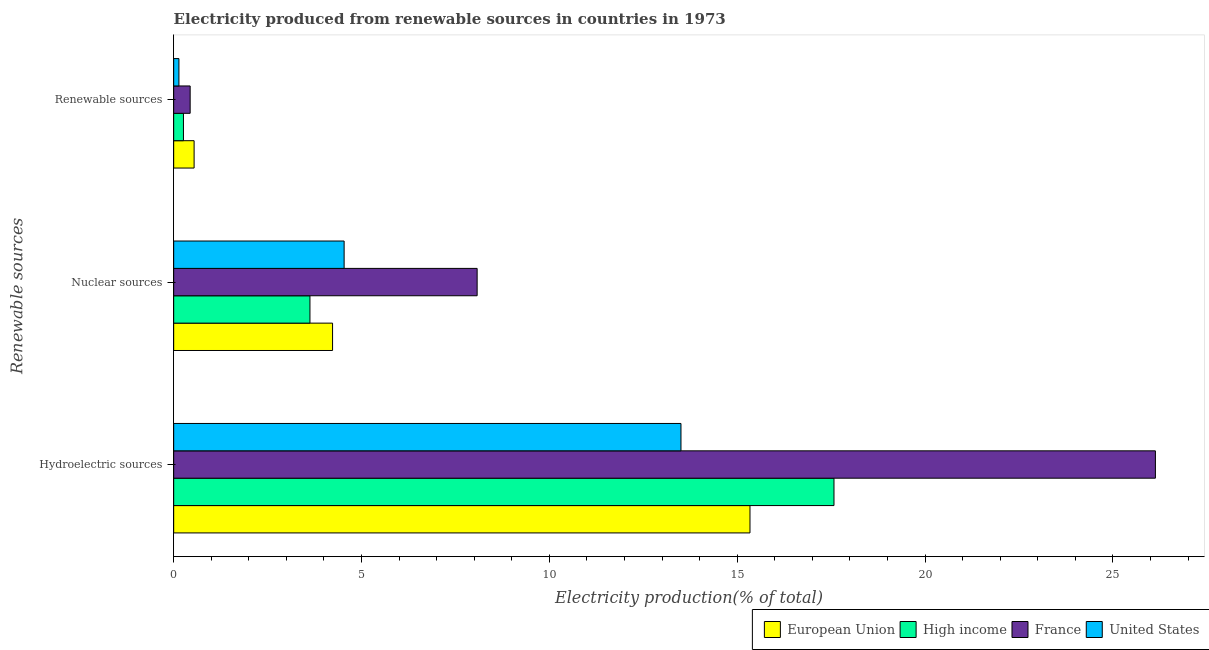How many groups of bars are there?
Your response must be concise. 3. Are the number of bars on each tick of the Y-axis equal?
Your answer should be very brief. Yes. How many bars are there on the 1st tick from the top?
Provide a short and direct response. 4. How many bars are there on the 2nd tick from the bottom?
Keep it short and to the point. 4. What is the label of the 1st group of bars from the top?
Provide a succinct answer. Renewable sources. What is the percentage of electricity produced by hydroelectric sources in United States?
Keep it short and to the point. 13.5. Across all countries, what is the maximum percentage of electricity produced by hydroelectric sources?
Make the answer very short. 26.13. Across all countries, what is the minimum percentage of electricity produced by hydroelectric sources?
Offer a terse response. 13.5. In which country was the percentage of electricity produced by nuclear sources minimum?
Provide a short and direct response. High income. What is the total percentage of electricity produced by renewable sources in the graph?
Provide a succinct answer. 1.38. What is the difference between the percentage of electricity produced by hydroelectric sources in France and that in European Union?
Provide a short and direct response. 10.79. What is the difference between the percentage of electricity produced by renewable sources in France and the percentage of electricity produced by hydroelectric sources in High income?
Make the answer very short. -17.14. What is the average percentage of electricity produced by nuclear sources per country?
Your answer should be very brief. 5.12. What is the difference between the percentage of electricity produced by nuclear sources and percentage of electricity produced by renewable sources in France?
Offer a terse response. 7.64. What is the ratio of the percentage of electricity produced by nuclear sources in France to that in United States?
Your response must be concise. 1.78. Is the difference between the percentage of electricity produced by hydroelectric sources in France and High income greater than the difference between the percentage of electricity produced by renewable sources in France and High income?
Offer a very short reply. Yes. What is the difference between the highest and the second highest percentage of electricity produced by hydroelectric sources?
Give a very brief answer. 8.55. What is the difference between the highest and the lowest percentage of electricity produced by hydroelectric sources?
Give a very brief answer. 12.63. What does the 3rd bar from the top in Hydroelectric sources represents?
Provide a short and direct response. High income. What does the 4th bar from the bottom in Nuclear sources represents?
Provide a short and direct response. United States. Is it the case that in every country, the sum of the percentage of electricity produced by hydroelectric sources and percentage of electricity produced by nuclear sources is greater than the percentage of electricity produced by renewable sources?
Ensure brevity in your answer.  Yes. How many bars are there?
Make the answer very short. 12. How many countries are there in the graph?
Ensure brevity in your answer.  4. Are the values on the major ticks of X-axis written in scientific E-notation?
Ensure brevity in your answer.  No. Where does the legend appear in the graph?
Your answer should be compact. Bottom right. How many legend labels are there?
Make the answer very short. 4. What is the title of the graph?
Make the answer very short. Electricity produced from renewable sources in countries in 1973. What is the label or title of the X-axis?
Your response must be concise. Electricity production(% of total). What is the label or title of the Y-axis?
Keep it short and to the point. Renewable sources. What is the Electricity production(% of total) of European Union in Hydroelectric sources?
Make the answer very short. 15.34. What is the Electricity production(% of total) in High income in Hydroelectric sources?
Your response must be concise. 17.57. What is the Electricity production(% of total) of France in Hydroelectric sources?
Provide a succinct answer. 26.13. What is the Electricity production(% of total) in United States in Hydroelectric sources?
Ensure brevity in your answer.  13.5. What is the Electricity production(% of total) of European Union in Nuclear sources?
Offer a terse response. 4.23. What is the Electricity production(% of total) of High income in Nuclear sources?
Provide a succinct answer. 3.63. What is the Electricity production(% of total) in France in Nuclear sources?
Your answer should be very brief. 8.08. What is the Electricity production(% of total) in United States in Nuclear sources?
Ensure brevity in your answer.  4.54. What is the Electricity production(% of total) in European Union in Renewable sources?
Your response must be concise. 0.54. What is the Electricity production(% of total) of High income in Renewable sources?
Give a very brief answer. 0.26. What is the Electricity production(% of total) in France in Renewable sources?
Provide a short and direct response. 0.44. What is the Electricity production(% of total) in United States in Renewable sources?
Ensure brevity in your answer.  0.14. Across all Renewable sources, what is the maximum Electricity production(% of total) in European Union?
Offer a terse response. 15.34. Across all Renewable sources, what is the maximum Electricity production(% of total) of High income?
Your answer should be very brief. 17.57. Across all Renewable sources, what is the maximum Electricity production(% of total) of France?
Offer a terse response. 26.13. Across all Renewable sources, what is the maximum Electricity production(% of total) in United States?
Offer a terse response. 13.5. Across all Renewable sources, what is the minimum Electricity production(% of total) in European Union?
Provide a short and direct response. 0.54. Across all Renewable sources, what is the minimum Electricity production(% of total) in High income?
Your answer should be very brief. 0.26. Across all Renewable sources, what is the minimum Electricity production(% of total) in France?
Your response must be concise. 0.44. Across all Renewable sources, what is the minimum Electricity production(% of total) in United States?
Make the answer very short. 0.14. What is the total Electricity production(% of total) in European Union in the graph?
Your response must be concise. 20.11. What is the total Electricity production(% of total) in High income in the graph?
Make the answer very short. 21.46. What is the total Electricity production(% of total) in France in the graph?
Provide a short and direct response. 34.65. What is the total Electricity production(% of total) in United States in the graph?
Provide a succinct answer. 18.18. What is the difference between the Electricity production(% of total) in European Union in Hydroelectric sources and that in Nuclear sources?
Your response must be concise. 11.11. What is the difference between the Electricity production(% of total) of High income in Hydroelectric sources and that in Nuclear sources?
Offer a very short reply. 13.95. What is the difference between the Electricity production(% of total) in France in Hydroelectric sources and that in Nuclear sources?
Offer a very short reply. 18.05. What is the difference between the Electricity production(% of total) in United States in Hydroelectric sources and that in Nuclear sources?
Provide a succinct answer. 8.97. What is the difference between the Electricity production(% of total) in European Union in Hydroelectric sources and that in Renewable sources?
Provide a succinct answer. 14.79. What is the difference between the Electricity production(% of total) of High income in Hydroelectric sources and that in Renewable sources?
Offer a terse response. 17.31. What is the difference between the Electricity production(% of total) in France in Hydroelectric sources and that in Renewable sources?
Offer a terse response. 25.69. What is the difference between the Electricity production(% of total) in United States in Hydroelectric sources and that in Renewable sources?
Offer a terse response. 13.36. What is the difference between the Electricity production(% of total) of European Union in Nuclear sources and that in Renewable sources?
Your answer should be compact. 3.68. What is the difference between the Electricity production(% of total) of High income in Nuclear sources and that in Renewable sources?
Your response must be concise. 3.37. What is the difference between the Electricity production(% of total) of France in Nuclear sources and that in Renewable sources?
Offer a terse response. 7.64. What is the difference between the Electricity production(% of total) of United States in Nuclear sources and that in Renewable sources?
Make the answer very short. 4.4. What is the difference between the Electricity production(% of total) in European Union in Hydroelectric sources and the Electricity production(% of total) in High income in Nuclear sources?
Offer a terse response. 11.71. What is the difference between the Electricity production(% of total) in European Union in Hydroelectric sources and the Electricity production(% of total) in France in Nuclear sources?
Your answer should be compact. 7.26. What is the difference between the Electricity production(% of total) of European Union in Hydroelectric sources and the Electricity production(% of total) of United States in Nuclear sources?
Offer a terse response. 10.8. What is the difference between the Electricity production(% of total) of High income in Hydroelectric sources and the Electricity production(% of total) of France in Nuclear sources?
Provide a succinct answer. 9.5. What is the difference between the Electricity production(% of total) in High income in Hydroelectric sources and the Electricity production(% of total) in United States in Nuclear sources?
Your response must be concise. 13.04. What is the difference between the Electricity production(% of total) of France in Hydroelectric sources and the Electricity production(% of total) of United States in Nuclear sources?
Offer a very short reply. 21.59. What is the difference between the Electricity production(% of total) of European Union in Hydroelectric sources and the Electricity production(% of total) of High income in Renewable sources?
Keep it short and to the point. 15.08. What is the difference between the Electricity production(% of total) of European Union in Hydroelectric sources and the Electricity production(% of total) of France in Renewable sources?
Your answer should be compact. 14.9. What is the difference between the Electricity production(% of total) in European Union in Hydroelectric sources and the Electricity production(% of total) in United States in Renewable sources?
Ensure brevity in your answer.  15.2. What is the difference between the Electricity production(% of total) in High income in Hydroelectric sources and the Electricity production(% of total) in France in Renewable sources?
Offer a very short reply. 17.14. What is the difference between the Electricity production(% of total) in High income in Hydroelectric sources and the Electricity production(% of total) in United States in Renewable sources?
Your response must be concise. 17.43. What is the difference between the Electricity production(% of total) of France in Hydroelectric sources and the Electricity production(% of total) of United States in Renewable sources?
Offer a very short reply. 25.99. What is the difference between the Electricity production(% of total) of European Union in Nuclear sources and the Electricity production(% of total) of High income in Renewable sources?
Your answer should be compact. 3.97. What is the difference between the Electricity production(% of total) in European Union in Nuclear sources and the Electricity production(% of total) in France in Renewable sources?
Provide a short and direct response. 3.79. What is the difference between the Electricity production(% of total) of European Union in Nuclear sources and the Electricity production(% of total) of United States in Renewable sources?
Make the answer very short. 4.09. What is the difference between the Electricity production(% of total) of High income in Nuclear sources and the Electricity production(% of total) of France in Renewable sources?
Your answer should be compact. 3.19. What is the difference between the Electricity production(% of total) of High income in Nuclear sources and the Electricity production(% of total) of United States in Renewable sources?
Your answer should be very brief. 3.49. What is the difference between the Electricity production(% of total) in France in Nuclear sources and the Electricity production(% of total) in United States in Renewable sources?
Your answer should be compact. 7.94. What is the average Electricity production(% of total) in European Union per Renewable sources?
Your answer should be compact. 6.7. What is the average Electricity production(% of total) in High income per Renewable sources?
Ensure brevity in your answer.  7.15. What is the average Electricity production(% of total) of France per Renewable sources?
Give a very brief answer. 11.55. What is the average Electricity production(% of total) of United States per Renewable sources?
Keep it short and to the point. 6.06. What is the difference between the Electricity production(% of total) in European Union and Electricity production(% of total) in High income in Hydroelectric sources?
Your response must be concise. -2.24. What is the difference between the Electricity production(% of total) in European Union and Electricity production(% of total) in France in Hydroelectric sources?
Provide a succinct answer. -10.79. What is the difference between the Electricity production(% of total) of European Union and Electricity production(% of total) of United States in Hydroelectric sources?
Your answer should be compact. 1.84. What is the difference between the Electricity production(% of total) of High income and Electricity production(% of total) of France in Hydroelectric sources?
Your answer should be compact. -8.55. What is the difference between the Electricity production(% of total) in High income and Electricity production(% of total) in United States in Hydroelectric sources?
Make the answer very short. 4.07. What is the difference between the Electricity production(% of total) of France and Electricity production(% of total) of United States in Hydroelectric sources?
Offer a terse response. 12.63. What is the difference between the Electricity production(% of total) in European Union and Electricity production(% of total) in High income in Nuclear sources?
Ensure brevity in your answer.  0.6. What is the difference between the Electricity production(% of total) in European Union and Electricity production(% of total) in France in Nuclear sources?
Provide a succinct answer. -3.85. What is the difference between the Electricity production(% of total) in European Union and Electricity production(% of total) in United States in Nuclear sources?
Provide a succinct answer. -0.31. What is the difference between the Electricity production(% of total) of High income and Electricity production(% of total) of France in Nuclear sources?
Make the answer very short. -4.45. What is the difference between the Electricity production(% of total) of High income and Electricity production(% of total) of United States in Nuclear sources?
Ensure brevity in your answer.  -0.91. What is the difference between the Electricity production(% of total) of France and Electricity production(% of total) of United States in Nuclear sources?
Provide a short and direct response. 3.54. What is the difference between the Electricity production(% of total) in European Union and Electricity production(% of total) in High income in Renewable sources?
Give a very brief answer. 0.28. What is the difference between the Electricity production(% of total) of European Union and Electricity production(% of total) of France in Renewable sources?
Provide a short and direct response. 0.11. What is the difference between the Electricity production(% of total) in European Union and Electricity production(% of total) in United States in Renewable sources?
Offer a very short reply. 0.4. What is the difference between the Electricity production(% of total) of High income and Electricity production(% of total) of France in Renewable sources?
Give a very brief answer. -0.18. What is the difference between the Electricity production(% of total) of High income and Electricity production(% of total) of United States in Renewable sources?
Provide a succinct answer. 0.12. What is the difference between the Electricity production(% of total) in France and Electricity production(% of total) in United States in Renewable sources?
Offer a terse response. 0.3. What is the ratio of the Electricity production(% of total) of European Union in Hydroelectric sources to that in Nuclear sources?
Provide a short and direct response. 3.63. What is the ratio of the Electricity production(% of total) of High income in Hydroelectric sources to that in Nuclear sources?
Offer a very short reply. 4.85. What is the ratio of the Electricity production(% of total) of France in Hydroelectric sources to that in Nuclear sources?
Provide a short and direct response. 3.24. What is the ratio of the Electricity production(% of total) in United States in Hydroelectric sources to that in Nuclear sources?
Provide a succinct answer. 2.98. What is the ratio of the Electricity production(% of total) in European Union in Hydroelectric sources to that in Renewable sources?
Provide a succinct answer. 28.2. What is the ratio of the Electricity production(% of total) in High income in Hydroelectric sources to that in Renewable sources?
Provide a succinct answer. 67.53. What is the ratio of the Electricity production(% of total) in France in Hydroelectric sources to that in Renewable sources?
Give a very brief answer. 59.54. What is the ratio of the Electricity production(% of total) of United States in Hydroelectric sources to that in Renewable sources?
Make the answer very short. 96.57. What is the ratio of the Electricity production(% of total) of European Union in Nuclear sources to that in Renewable sources?
Your answer should be very brief. 7.77. What is the ratio of the Electricity production(% of total) in High income in Nuclear sources to that in Renewable sources?
Provide a short and direct response. 13.94. What is the ratio of the Electricity production(% of total) in France in Nuclear sources to that in Renewable sources?
Ensure brevity in your answer.  18.4. What is the ratio of the Electricity production(% of total) of United States in Nuclear sources to that in Renewable sources?
Your answer should be very brief. 32.45. What is the difference between the highest and the second highest Electricity production(% of total) in European Union?
Your response must be concise. 11.11. What is the difference between the highest and the second highest Electricity production(% of total) in High income?
Provide a short and direct response. 13.95. What is the difference between the highest and the second highest Electricity production(% of total) in France?
Provide a short and direct response. 18.05. What is the difference between the highest and the second highest Electricity production(% of total) of United States?
Offer a very short reply. 8.97. What is the difference between the highest and the lowest Electricity production(% of total) in European Union?
Ensure brevity in your answer.  14.79. What is the difference between the highest and the lowest Electricity production(% of total) in High income?
Give a very brief answer. 17.31. What is the difference between the highest and the lowest Electricity production(% of total) in France?
Offer a terse response. 25.69. What is the difference between the highest and the lowest Electricity production(% of total) in United States?
Offer a terse response. 13.36. 